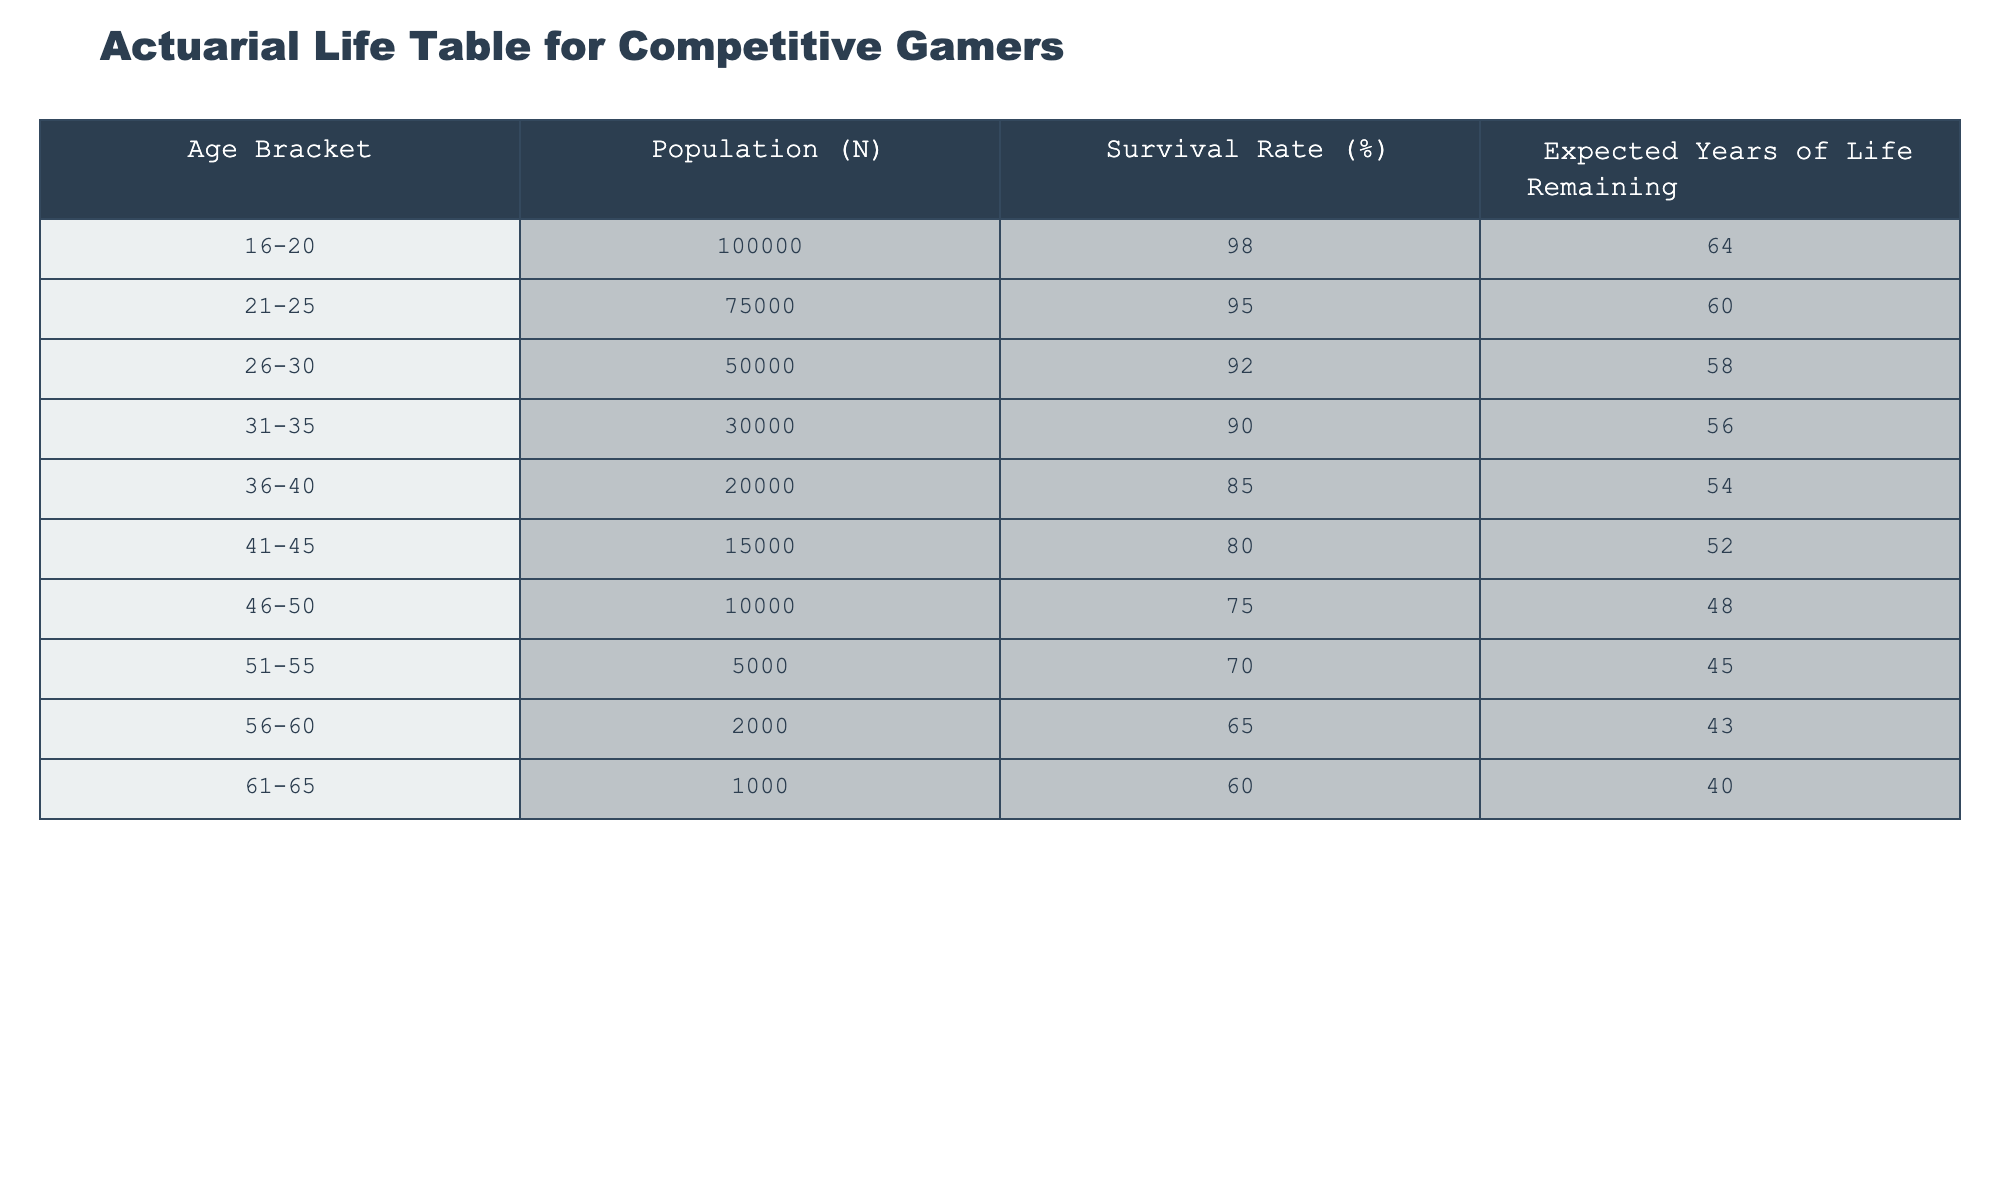What is the survival rate for the age bracket 36-40? The survival rate is explicitly listed in the table for each age bracket. For the age bracket 36-40, the survival rate is stated as 85%.
Answer: 85% Which age bracket has the highest expected years of life remaining? To find this, we look at the expected years of life remaining for each age bracket in the table. The age bracket 16-20 has 64 expected years of life remaining, which is higher than any other bracket.
Answer: 16-20 How many total people are in the age brackets 41-45 and 46-50 combined? We add the populations from both age brackets. For 41-45, the population is 15,000, and for 46-50, it is 10,000. Therefore, 15,000 + 10,000 = 25,000 total.
Answer: 25000 Is the survival rate for the age group 51-55 greater than the survival rate for the age group 56-60? Looking at the data, the survival rate for 51-55 is 70%, while for 56-60 it is 65%. Since 70% > 65%, the answer is yes.
Answer: Yes What is the difference in expected years of life remaining between the age brackets 26-30 and 31-35? The expected years of life remaining for 26-30 is 58 and for 31-35 it is 56. We subtract these two values: 58 - 56 = 2 expected years difference.
Answer: 2 Which age group has the lowest population? From the table, we see that the age bracket 56-60 has the lowest population, with only 2,000 people recorded.
Answer: 56-60 What is the average survival rate across all age brackets? To find the average survival rate, we sum the survival rates: 98 + 95 + 92 + 90 + 85 + 80 + 75 + 70 + 65 + 60 =  950. There are 10 age brackets, so the average is 950 / 10 = 95%.
Answer: 95% Are there more people in the age bracket 21-25 than in the age bracket 41-45? The population for 21-25 is 75,000 while for 41-45 it is 15,000. Thus, there are indeed more people in the 21-25 bracket.
Answer: Yes What is the total population of competitive gamers aged 30 or younger? We will add the populations of the age brackets 16-20, 21-25, and 26-30. That is 100,000 + 75,000 + 50,000 = 225,000 total.
Answer: 225000 